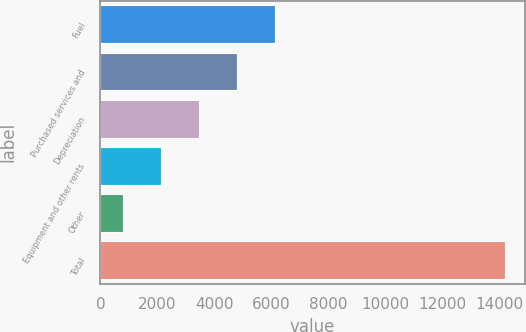Convert chart to OTSL. <chart><loc_0><loc_0><loc_500><loc_500><bar_chart><fcel>Fuel<fcel>Purchased services and<fcel>Depreciation<fcel>Equipment and other rents<fcel>Other<fcel>Total<nl><fcel>6145.2<fcel>4805.9<fcel>3466.6<fcel>2127.3<fcel>788<fcel>14181<nl></chart> 